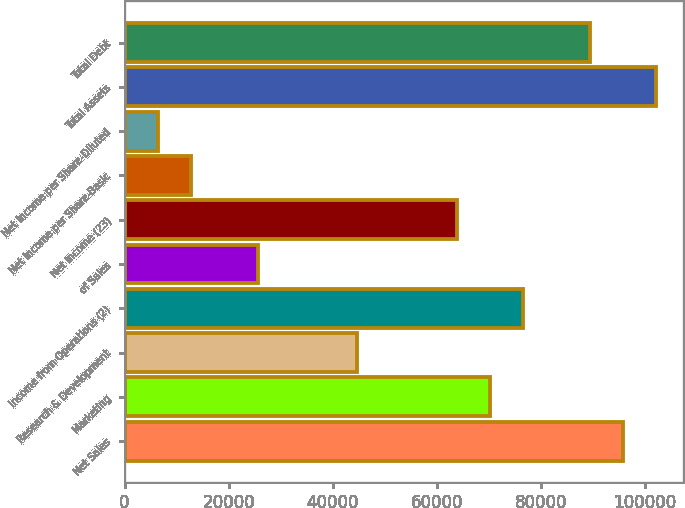Convert chart. <chart><loc_0><loc_0><loc_500><loc_500><bar_chart><fcel>Net Sales<fcel>Marketing<fcel>Research & Development<fcel>Income from Operations (2)<fcel>of Sales<fcel>Net Income (23)<fcel>Net Income per Share-Basic<fcel>Net Income per Share-Diluted<fcel>Total Assets<fcel>Total Debt<nl><fcel>95785.4<fcel>70242.7<fcel>44700<fcel>76628.4<fcel>25543<fcel>63857<fcel>12771.6<fcel>6385.92<fcel>102171<fcel>89399.8<nl></chart> 